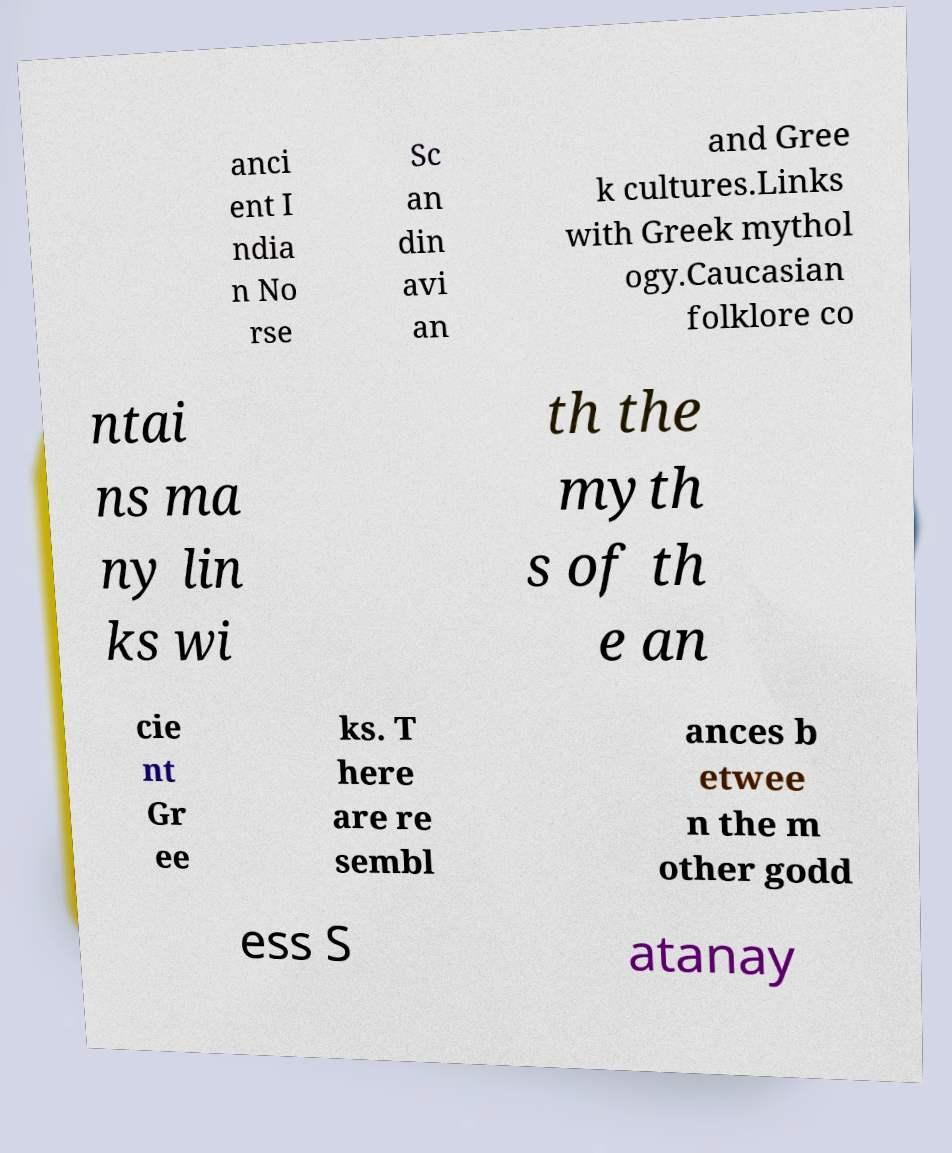For documentation purposes, I need the text within this image transcribed. Could you provide that? anci ent I ndia n No rse Sc an din avi an and Gree k cultures.Links with Greek mythol ogy.Caucasian folklore co ntai ns ma ny lin ks wi th the myth s of th e an cie nt Gr ee ks. T here are re sembl ances b etwee n the m other godd ess S atanay 